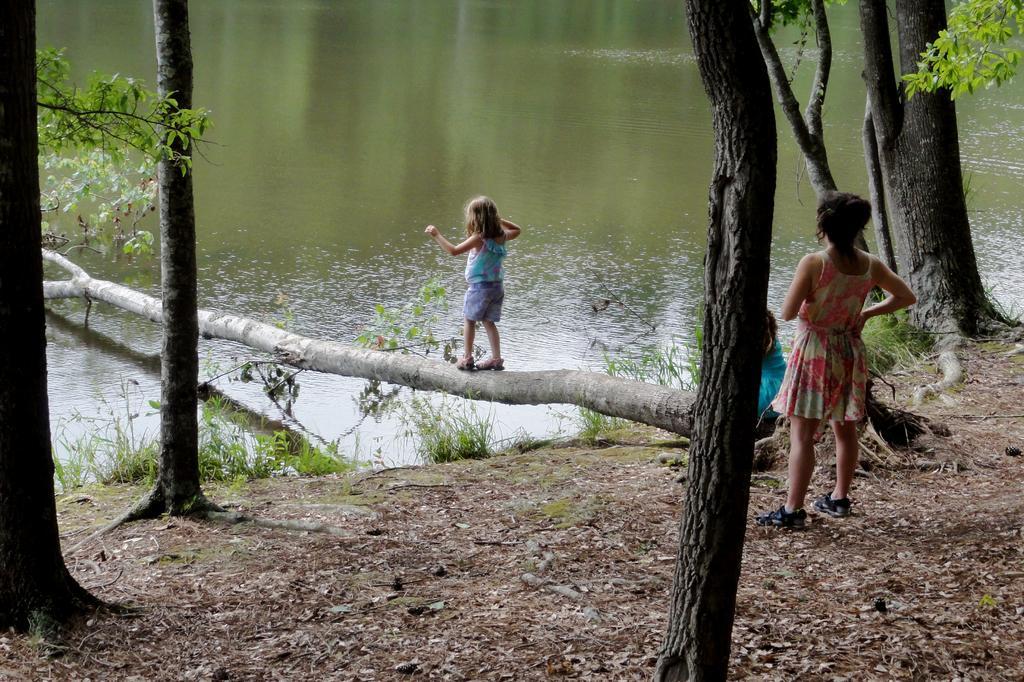Please provide a concise description of this image. In this image there is a river a tree fallen into the river on that tree a girl is walking, beside that there is a land on that land there is a trees, a woman is standing in front of the tree. 